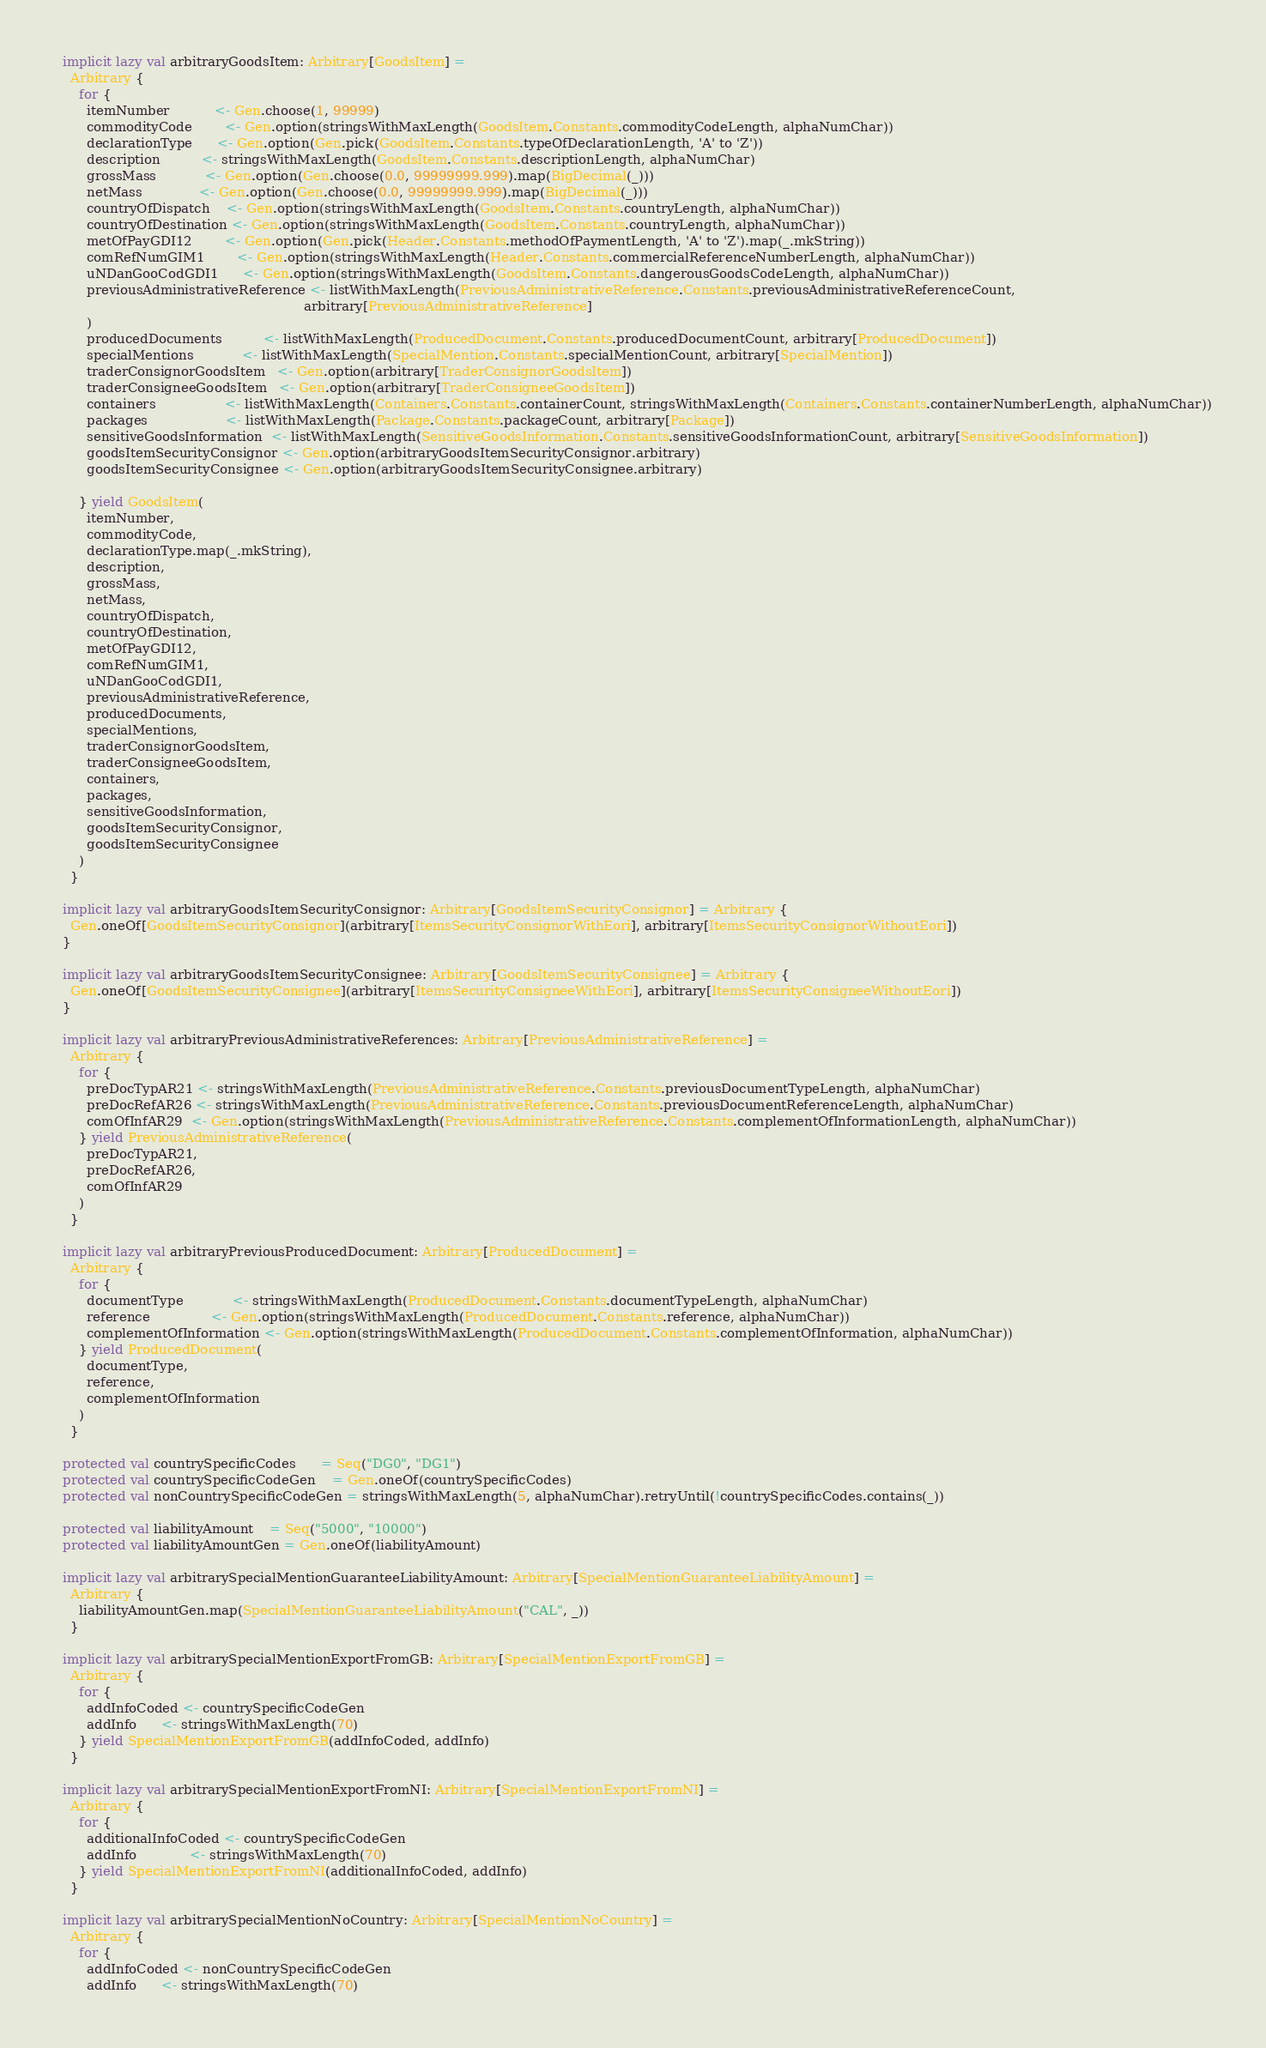Convert code to text. <code><loc_0><loc_0><loc_500><loc_500><_Scala_>
  implicit lazy val arbitraryGoodsItem: Arbitrary[GoodsItem] =
    Arbitrary {
      for {
        itemNumber           <- Gen.choose(1, 99999)
        commodityCode        <- Gen.option(stringsWithMaxLength(GoodsItem.Constants.commodityCodeLength, alphaNumChar))
        declarationType      <- Gen.option(Gen.pick(GoodsItem.Constants.typeOfDeclarationLength, 'A' to 'Z'))
        description          <- stringsWithMaxLength(GoodsItem.Constants.descriptionLength, alphaNumChar)
        grossMass            <- Gen.option(Gen.choose(0.0, 99999999.999).map(BigDecimal(_)))
        netMass              <- Gen.option(Gen.choose(0.0, 99999999.999).map(BigDecimal(_)))
        countryOfDispatch    <- Gen.option(stringsWithMaxLength(GoodsItem.Constants.countryLength, alphaNumChar))
        countryOfDestination <- Gen.option(stringsWithMaxLength(GoodsItem.Constants.countryLength, alphaNumChar))
        metOfPayGDI12        <- Gen.option(Gen.pick(Header.Constants.methodOfPaymentLength, 'A' to 'Z').map(_.mkString))
        comRefNumGIM1        <- Gen.option(stringsWithMaxLength(Header.Constants.commercialReferenceNumberLength, alphaNumChar))
        uNDanGooCodGDI1      <- Gen.option(stringsWithMaxLength(GoodsItem.Constants.dangerousGoodsCodeLength, alphaNumChar))
        previousAdministrativeReference <- listWithMaxLength(PreviousAdministrativeReference.Constants.previousAdministrativeReferenceCount,
                                                             arbitrary[PreviousAdministrativeReference]
        )
        producedDocuments          <- listWithMaxLength(ProducedDocument.Constants.producedDocumentCount, arbitrary[ProducedDocument])
        specialMentions            <- listWithMaxLength(SpecialMention.Constants.specialMentionCount, arbitrary[SpecialMention])
        traderConsignorGoodsItem   <- Gen.option(arbitrary[TraderConsignorGoodsItem])
        traderConsigneeGoodsItem   <- Gen.option(arbitrary[TraderConsigneeGoodsItem])
        containers                 <- listWithMaxLength(Containers.Constants.containerCount, stringsWithMaxLength(Containers.Constants.containerNumberLength, alphaNumChar))
        packages                   <- listWithMaxLength(Package.Constants.packageCount, arbitrary[Package])
        sensitiveGoodsInformation  <- listWithMaxLength(SensitiveGoodsInformation.Constants.sensitiveGoodsInformationCount, arbitrary[SensitiveGoodsInformation])
        goodsItemSecurityConsignor <- Gen.option(arbitraryGoodsItemSecurityConsignor.arbitrary)
        goodsItemSecurityConsignee <- Gen.option(arbitraryGoodsItemSecurityConsignee.arbitrary)

      } yield GoodsItem(
        itemNumber,
        commodityCode,
        declarationType.map(_.mkString),
        description,
        grossMass,
        netMass,
        countryOfDispatch,
        countryOfDestination,
        metOfPayGDI12,
        comRefNumGIM1,
        uNDanGooCodGDI1,
        previousAdministrativeReference,
        producedDocuments,
        specialMentions,
        traderConsignorGoodsItem,
        traderConsigneeGoodsItem,
        containers,
        packages,
        sensitiveGoodsInformation,
        goodsItemSecurityConsignor,
        goodsItemSecurityConsignee
      )
    }

  implicit lazy val arbitraryGoodsItemSecurityConsignor: Arbitrary[GoodsItemSecurityConsignor] = Arbitrary {
    Gen.oneOf[GoodsItemSecurityConsignor](arbitrary[ItemsSecurityConsignorWithEori], arbitrary[ItemsSecurityConsignorWithoutEori])
  }

  implicit lazy val arbitraryGoodsItemSecurityConsignee: Arbitrary[GoodsItemSecurityConsignee] = Arbitrary {
    Gen.oneOf[GoodsItemSecurityConsignee](arbitrary[ItemsSecurityConsigneeWithEori], arbitrary[ItemsSecurityConsigneeWithoutEori])
  }

  implicit lazy val arbitraryPreviousAdministrativeReferences: Arbitrary[PreviousAdministrativeReference] =
    Arbitrary {
      for {
        preDocTypAR21 <- stringsWithMaxLength(PreviousAdministrativeReference.Constants.previousDocumentTypeLength, alphaNumChar)
        preDocRefAR26 <- stringsWithMaxLength(PreviousAdministrativeReference.Constants.previousDocumentReferenceLength, alphaNumChar)
        comOfInfAR29  <- Gen.option(stringsWithMaxLength(PreviousAdministrativeReference.Constants.complementOfInformationLength, alphaNumChar))
      } yield PreviousAdministrativeReference(
        preDocTypAR21,
        preDocRefAR26,
        comOfInfAR29
      )
    }

  implicit lazy val arbitraryPreviousProducedDocument: Arbitrary[ProducedDocument] =
    Arbitrary {
      for {
        documentType            <- stringsWithMaxLength(ProducedDocument.Constants.documentTypeLength, alphaNumChar)
        reference               <- Gen.option(stringsWithMaxLength(ProducedDocument.Constants.reference, alphaNumChar))
        complementOfInformation <- Gen.option(stringsWithMaxLength(ProducedDocument.Constants.complementOfInformation, alphaNumChar))
      } yield ProducedDocument(
        documentType,
        reference,
        complementOfInformation
      )
    }

  protected val countrySpecificCodes      = Seq("DG0", "DG1")
  protected val countrySpecificCodeGen    = Gen.oneOf(countrySpecificCodes)
  protected val nonCountrySpecificCodeGen = stringsWithMaxLength(5, alphaNumChar).retryUntil(!countrySpecificCodes.contains(_))

  protected val liabilityAmount    = Seq("5000", "10000")
  protected val liabilityAmountGen = Gen.oneOf(liabilityAmount)

  implicit lazy val arbitrarySpecialMentionGuaranteeLiabilityAmount: Arbitrary[SpecialMentionGuaranteeLiabilityAmount] =
    Arbitrary {
      liabilityAmountGen.map(SpecialMentionGuaranteeLiabilityAmount("CAL", _))
    }

  implicit lazy val arbitrarySpecialMentionExportFromGB: Arbitrary[SpecialMentionExportFromGB] =
    Arbitrary {
      for {
        addInfoCoded <- countrySpecificCodeGen
        addInfo      <- stringsWithMaxLength(70)
      } yield SpecialMentionExportFromGB(addInfoCoded, addInfo)
    }

  implicit lazy val arbitrarySpecialMentionExportFromNI: Arbitrary[SpecialMentionExportFromNI] =
    Arbitrary {
      for {
        additionalInfoCoded <- countrySpecificCodeGen
        addInfo             <- stringsWithMaxLength(70)
      } yield SpecialMentionExportFromNI(additionalInfoCoded, addInfo)
    }

  implicit lazy val arbitrarySpecialMentionNoCountry: Arbitrary[SpecialMentionNoCountry] =
    Arbitrary {
      for {
        addInfoCoded <- nonCountrySpecificCodeGen
        addInfo      <- stringsWithMaxLength(70)</code> 